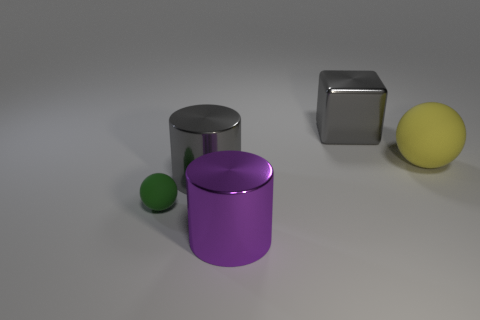Subtract all purple cylinders. How many cylinders are left? 1 Add 1 cyan shiny cylinders. How many objects exist? 6 Subtract 0 brown cylinders. How many objects are left? 5 Subtract all spheres. How many objects are left? 3 Subtract 1 blocks. How many blocks are left? 0 Subtract all gray balls. Subtract all purple cylinders. How many balls are left? 2 Subtract all purple cylinders. How many green spheres are left? 1 Subtract all matte cylinders. Subtract all big purple objects. How many objects are left? 4 Add 1 purple cylinders. How many purple cylinders are left? 2 Add 3 small green metallic cubes. How many small green metallic cubes exist? 3 